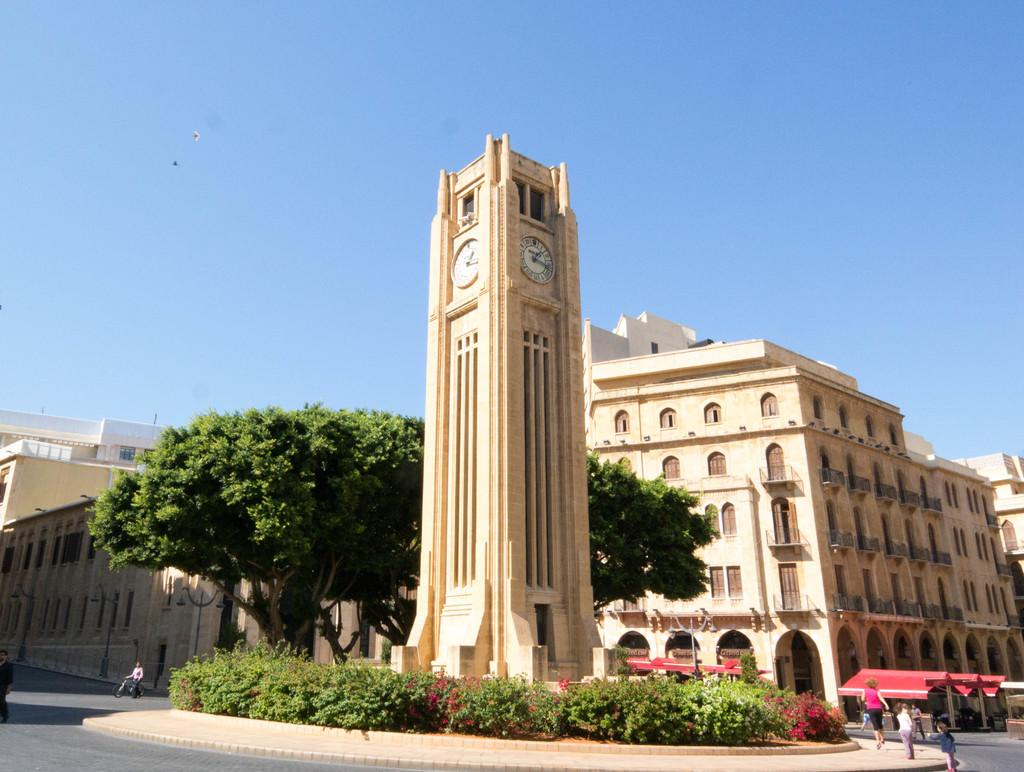Provide a one-sentence caption for the provided image. A street with a large clock tower that reads about 1:17. 